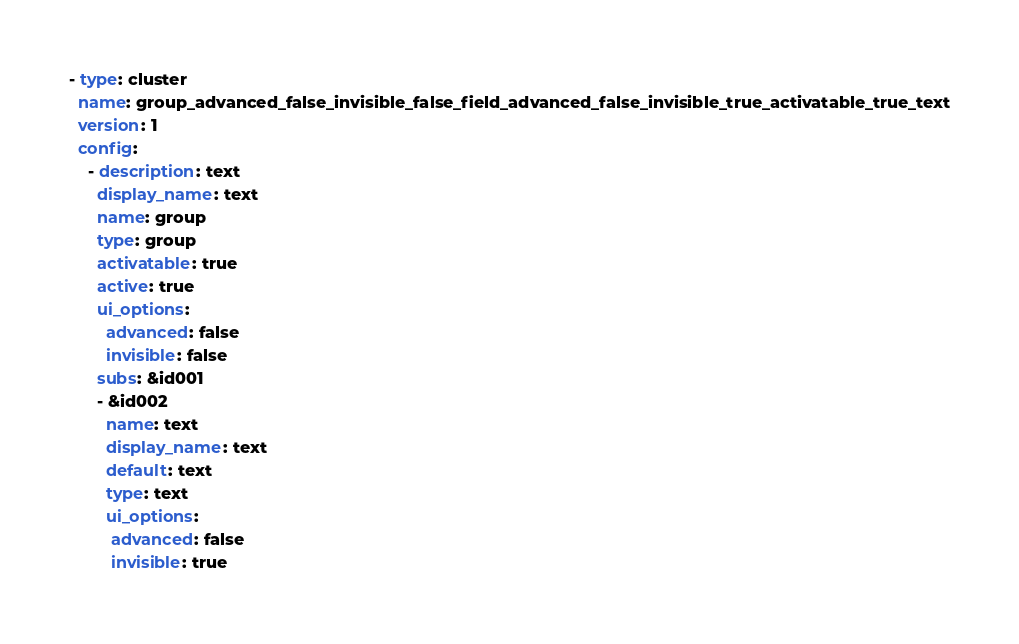Convert code to text. <code><loc_0><loc_0><loc_500><loc_500><_YAML_>
- type: cluster
  name: group_advanced_false_invisible_false_field_advanced_false_invisible_true_activatable_true_text
  version: 1
  config:
    - description: text
      display_name: text
      name: group
      type: group
      activatable: true
      active: true
      ui_options:
        advanced: false
        invisible: false
      subs: &id001
      - &id002
        name: text
        display_name: text
        default: text
        type: text
        ui_options:
         advanced: false
         invisible: true
</code> 